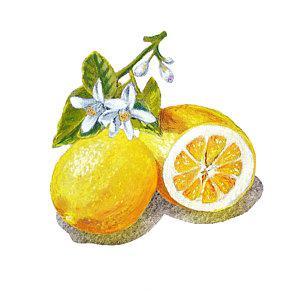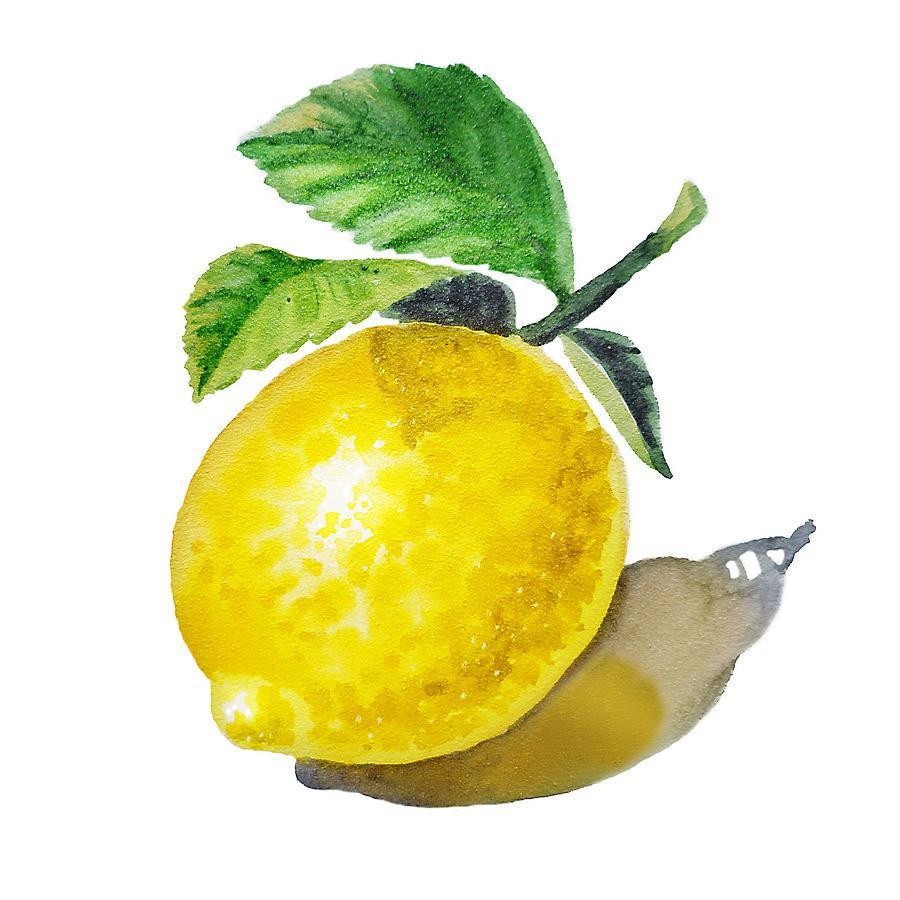The first image is the image on the left, the second image is the image on the right. Evaluate the accuracy of this statement regarding the images: "A stem and leaves are attached to a single lemon, while in a second image a lemon segment is beside one or more whole lemons.". Is it true? Answer yes or no. Yes. The first image is the image on the left, the second image is the image on the right. Analyze the images presented: Is the assertion "Each image includes a whole yellow fruit and a green leaf, one image includes a half-section of fruit, and no image shows unpicked fruit growing on a branch." valid? Answer yes or no. Yes. 